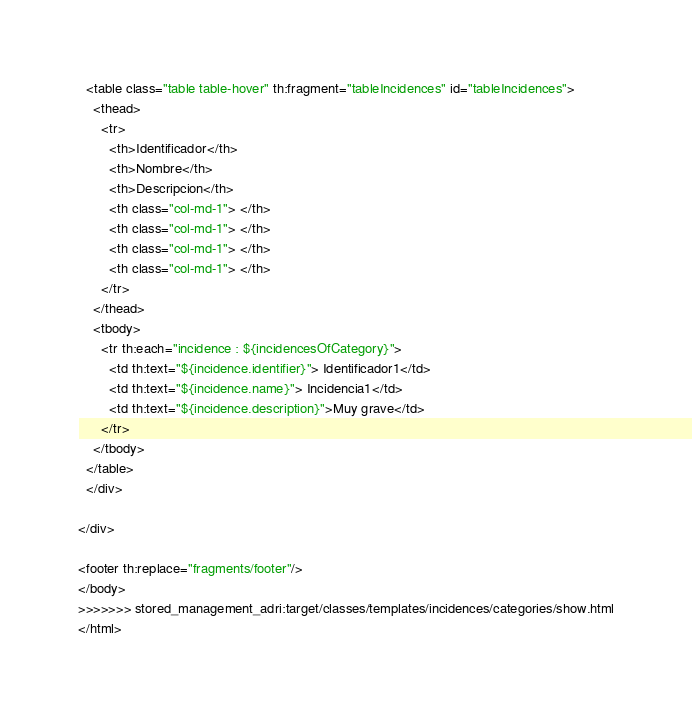Convert code to text. <code><loc_0><loc_0><loc_500><loc_500><_HTML_>  <table class="table table-hover" th:fragment="tableIncidences" id="tableIncidences">
    <thead>
      <tr>
        <th>Identificador</th>
        <th>Nombre</th>
        <th>Descripcion</th>
		<th class="col-md-1"> </th>
		<th class="col-md-1"> </th>
		<th class="col-md-1"> </th>
		<th class="col-md-1"> </th>
      </tr>
    </thead>
	<tbody>
	  <tr th:each="incidence : ${incidencesOfCategory}">
	    <td th:text="${incidence.identifier}"> Identificador1</td>
	    <td th:text="${incidence.name}"> Incidencia1</td>
	    <td th:text="${incidence.description}">Muy grave</td>
	  </tr>
	</tbody>
  </table>
  </div>

</div>

<footer th:replace="fragments/footer"/>
</body>
>>>>>>> stored_management_adri:target/classes/templates/incidences/categories/show.html
</html></code> 